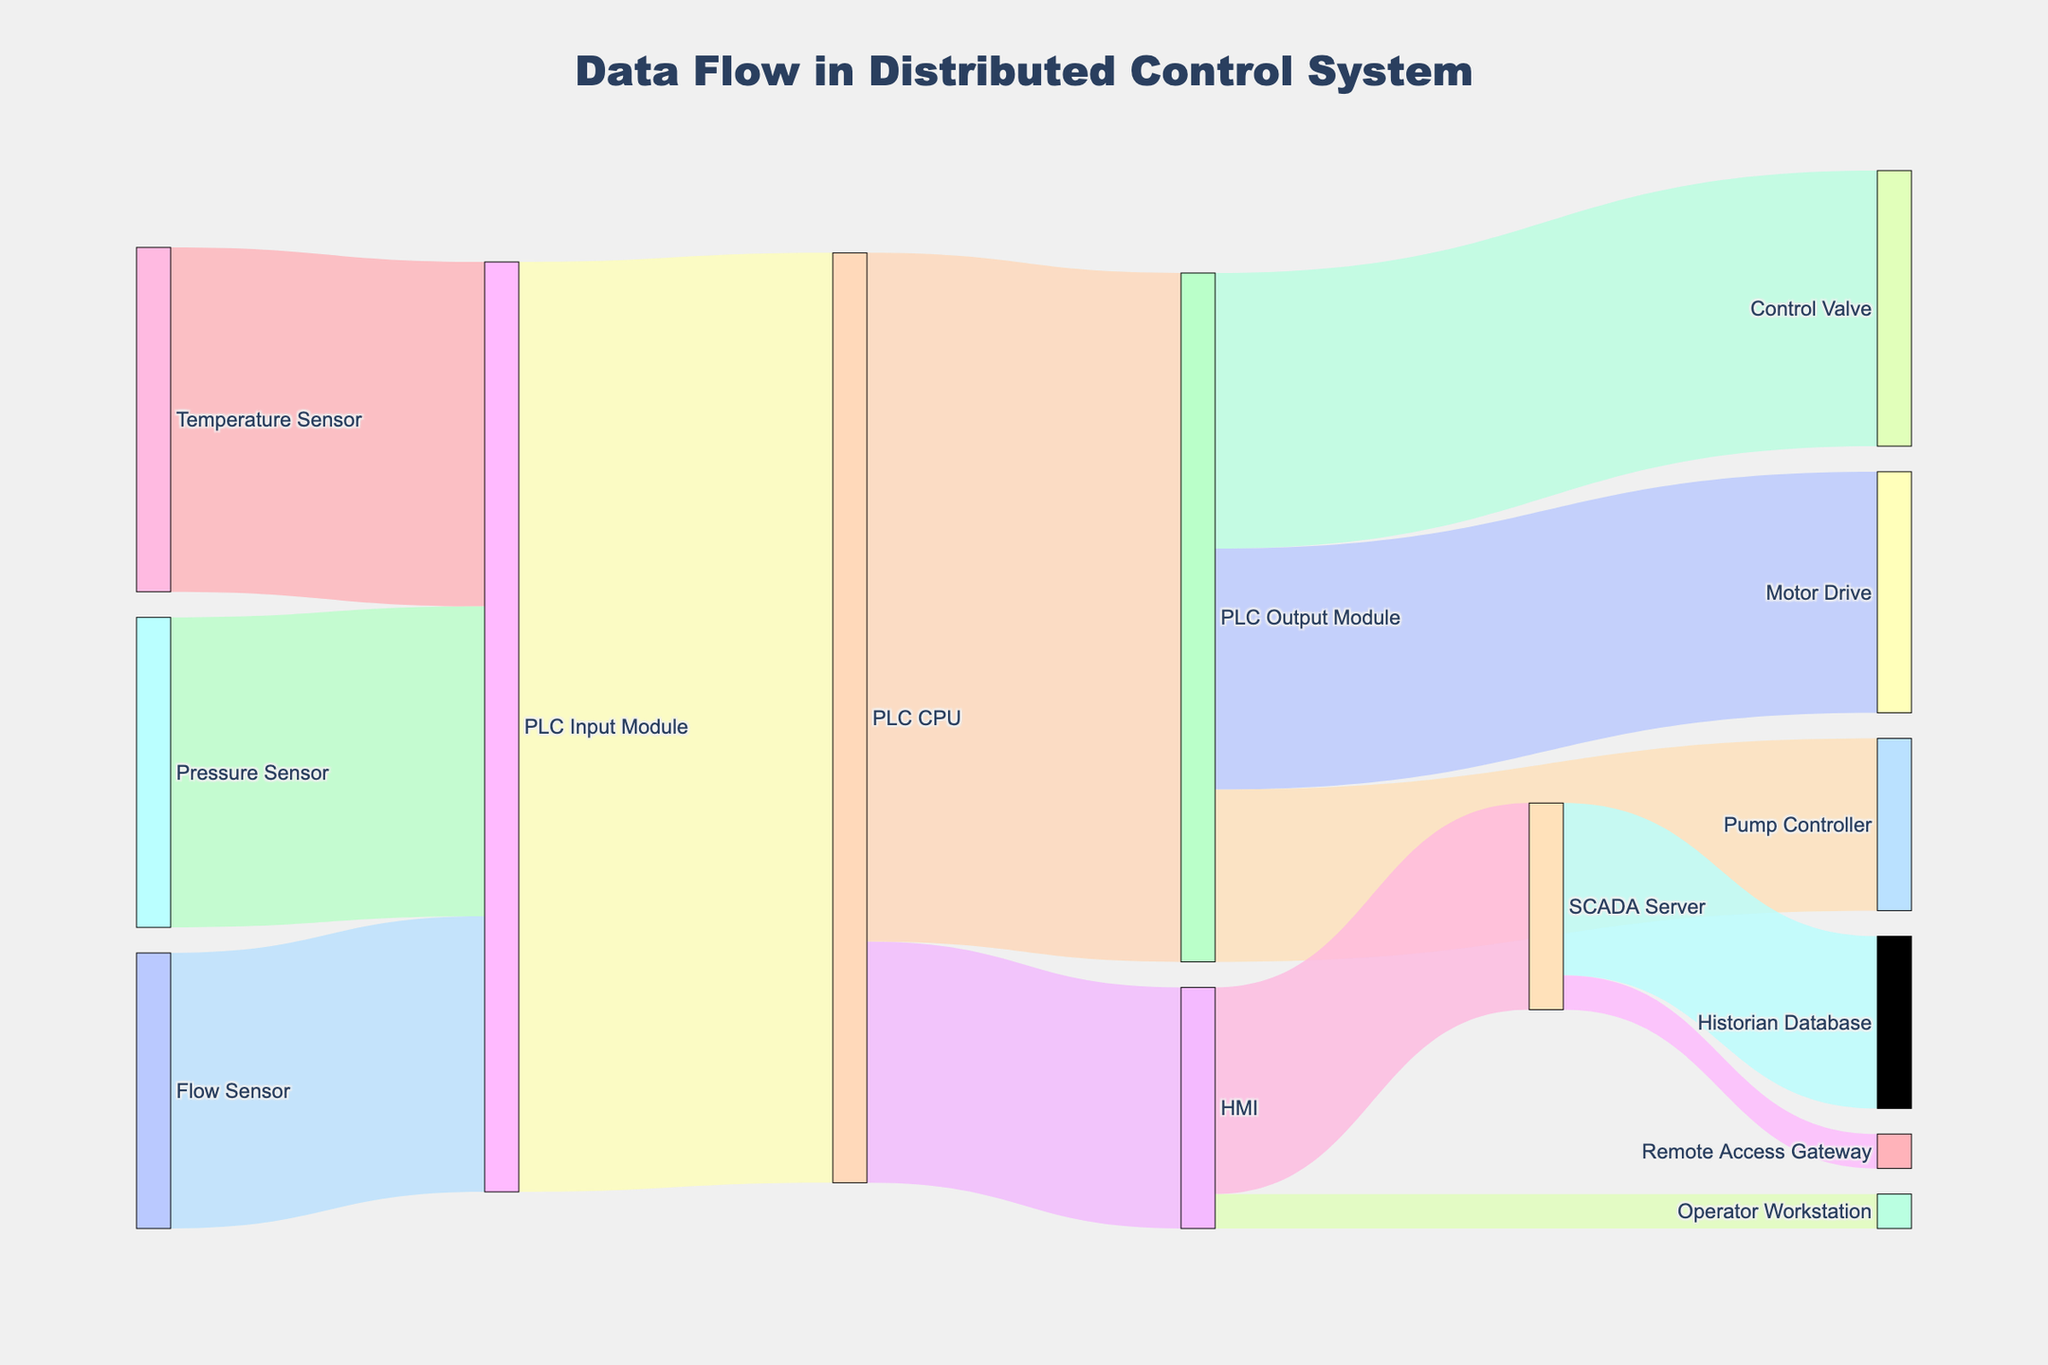What is the primary source to the PLC Input Module? The flows going into the PLC Input Module are from the Temperature Sensor, Pressure Sensor, and Flow Sensor. The values are 50, 45, and 40 respectively. Adding these up: 50 + 45 + 40 = 135. Hence, all three are significant, but the largest contribution comes from the Temperature Sensor with a value of 50.
Answer: Temperature Sensor How much data flows from the PLC CPU to the HMI? Looking at the link between PLC CPU and HMI, the sankey diagram shows a value of 35 for this connection.
Answer: 35 Compare the data flow from the HMI to the SCADA Server and the Historian Database. Which one has a greater value and by how much? The data flow from the HMI to the SCADA Server is 30, and the data flow to the Historian Database via SCADA Server is also 25. Comparing these values: 30 (HMI to SCADA Server) - 25 (SCADA Server to Historian Database) = 5. Therefore, the data flow from HMI to the SCADA Server is greater by 5.
Answer: SCADA Server by 5 Which connections involve a flow of exactly 40 units? From the diagram, the connections with a flow of exactly 40 units are from the Temperature Sensor to the PLC Input Module, and the PLC Output Module to the Control Valve.
Answer: Temperature Sensor to PLC Input Module, PLC Output Module to Control Valve What is the total data flow handled by the PLC CPU? To find the total data flow handled by the PLC CPU, calculate the sum of input and outputs:
Inputs: 135 (from PLC Input Module)
Outputs: 100 (to PLC Output Module) + 35 (to HMI) = 135. Therefore, total data flow is 135 + 135 = 270.
Answer: 270 How much more data does the SCADA Server send to the Historian Database compared to the Remote Access Gateway? The SCADA Server sends 25 units to the Historian Database and 5 units to the Remote Access Gateway. The difference is 25 - 5 = 20 units.
Answer: 20 units What is the flow of data from the PLC Output Module to the Control Valve, Motor Drive, and Pump Controller combined? Adding the values for each flow from the PLC Output Module:
Control Valve: 40
Motor Drive: 35
Pump Controller: 25
Total = 40 + 35 + 25 = 100
Answer: 100 Where does the HMI forward its data to, and what are the respective values? The HMI forwards its data to the SCADA Server and the Operator Workstation. The respective values are:
SCADA Server: 30
Operator Workstation: 5
Answer: SCADA Server: 30, Operator Workstation: 5 